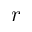<formula> <loc_0><loc_0><loc_500><loc_500>r</formula> 